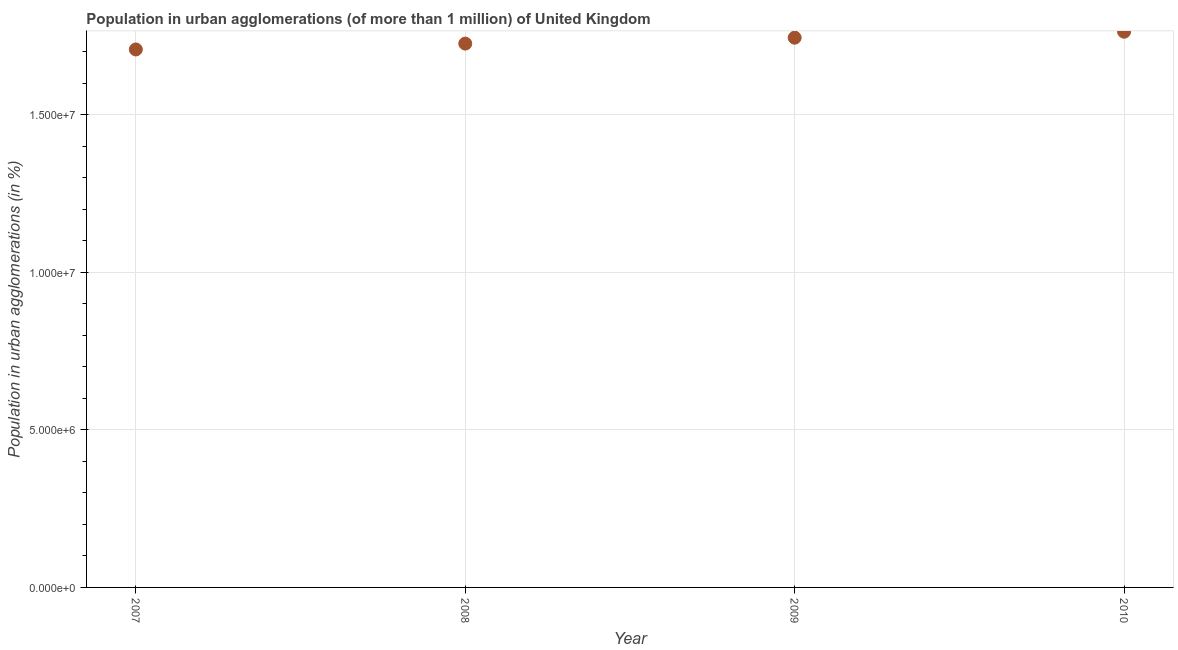What is the population in urban agglomerations in 2008?
Your response must be concise. 1.73e+07. Across all years, what is the maximum population in urban agglomerations?
Your answer should be compact. 1.76e+07. Across all years, what is the minimum population in urban agglomerations?
Your response must be concise. 1.71e+07. In which year was the population in urban agglomerations maximum?
Keep it short and to the point. 2010. What is the sum of the population in urban agglomerations?
Make the answer very short. 6.94e+07. What is the difference between the population in urban agglomerations in 2008 and 2010?
Your answer should be very brief. -3.77e+05. What is the average population in urban agglomerations per year?
Give a very brief answer. 1.73e+07. What is the median population in urban agglomerations?
Ensure brevity in your answer.  1.73e+07. Do a majority of the years between 2009 and 2010 (inclusive) have population in urban agglomerations greater than 3000000 %?
Your response must be concise. Yes. What is the ratio of the population in urban agglomerations in 2009 to that in 2010?
Ensure brevity in your answer.  0.99. What is the difference between the highest and the second highest population in urban agglomerations?
Offer a terse response. 1.90e+05. What is the difference between the highest and the lowest population in urban agglomerations?
Make the answer very short. 5.63e+05. What is the difference between two consecutive major ticks on the Y-axis?
Your answer should be compact. 5.00e+06. What is the title of the graph?
Ensure brevity in your answer.  Population in urban agglomerations (of more than 1 million) of United Kingdom. What is the label or title of the Y-axis?
Give a very brief answer. Population in urban agglomerations (in %). What is the Population in urban agglomerations (in %) in 2007?
Your answer should be compact. 1.71e+07. What is the Population in urban agglomerations (in %) in 2008?
Provide a short and direct response. 1.73e+07. What is the Population in urban agglomerations (in %) in 2009?
Provide a succinct answer. 1.74e+07. What is the Population in urban agglomerations (in %) in 2010?
Provide a short and direct response. 1.76e+07. What is the difference between the Population in urban agglomerations (in %) in 2007 and 2008?
Make the answer very short. -1.86e+05. What is the difference between the Population in urban agglomerations (in %) in 2007 and 2009?
Your answer should be compact. -3.73e+05. What is the difference between the Population in urban agglomerations (in %) in 2007 and 2010?
Your answer should be very brief. -5.63e+05. What is the difference between the Population in urban agglomerations (in %) in 2008 and 2009?
Provide a succinct answer. -1.87e+05. What is the difference between the Population in urban agglomerations (in %) in 2008 and 2010?
Give a very brief answer. -3.77e+05. What is the difference between the Population in urban agglomerations (in %) in 2009 and 2010?
Make the answer very short. -1.90e+05. What is the ratio of the Population in urban agglomerations (in %) in 2007 to that in 2008?
Ensure brevity in your answer.  0.99. What is the ratio of the Population in urban agglomerations (in %) in 2007 to that in 2009?
Your response must be concise. 0.98. What is the ratio of the Population in urban agglomerations (in %) in 2007 to that in 2010?
Offer a very short reply. 0.97. 